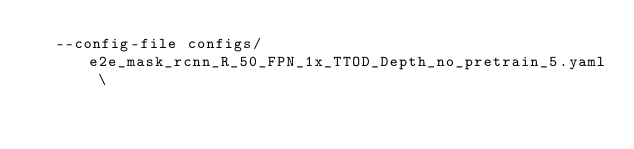<code> <loc_0><loc_0><loc_500><loc_500><_Bash_>  --config-file configs/e2e_mask_rcnn_R_50_FPN_1x_TTOD_Depth_no_pretrain_5.yaml \
</code> 